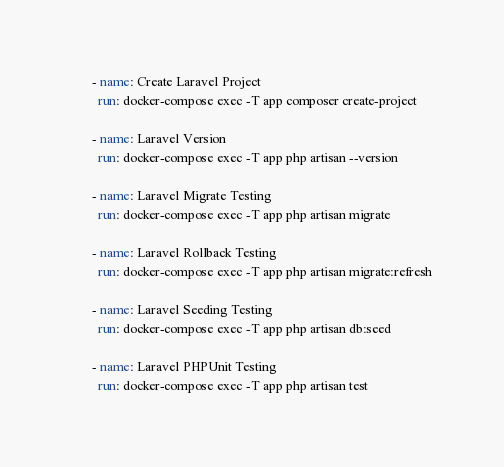<code> <loc_0><loc_0><loc_500><loc_500><_YAML_>
      - name: Create Laravel Project
        run: docker-compose exec -T app composer create-project

      - name: Laravel Version
        run: docker-compose exec -T app php artisan --version

      - name: Laravel Migrate Testing
        run: docker-compose exec -T app php artisan migrate

      - name: Laravel Rollback Testing
        run: docker-compose exec -T app php artisan migrate:refresh

      - name: Laravel Seeding Testing
        run: docker-compose exec -T app php artisan db:seed

      - name: Laravel PHPUnit Testing
        run: docker-compose exec -T app php artisan test
</code> 